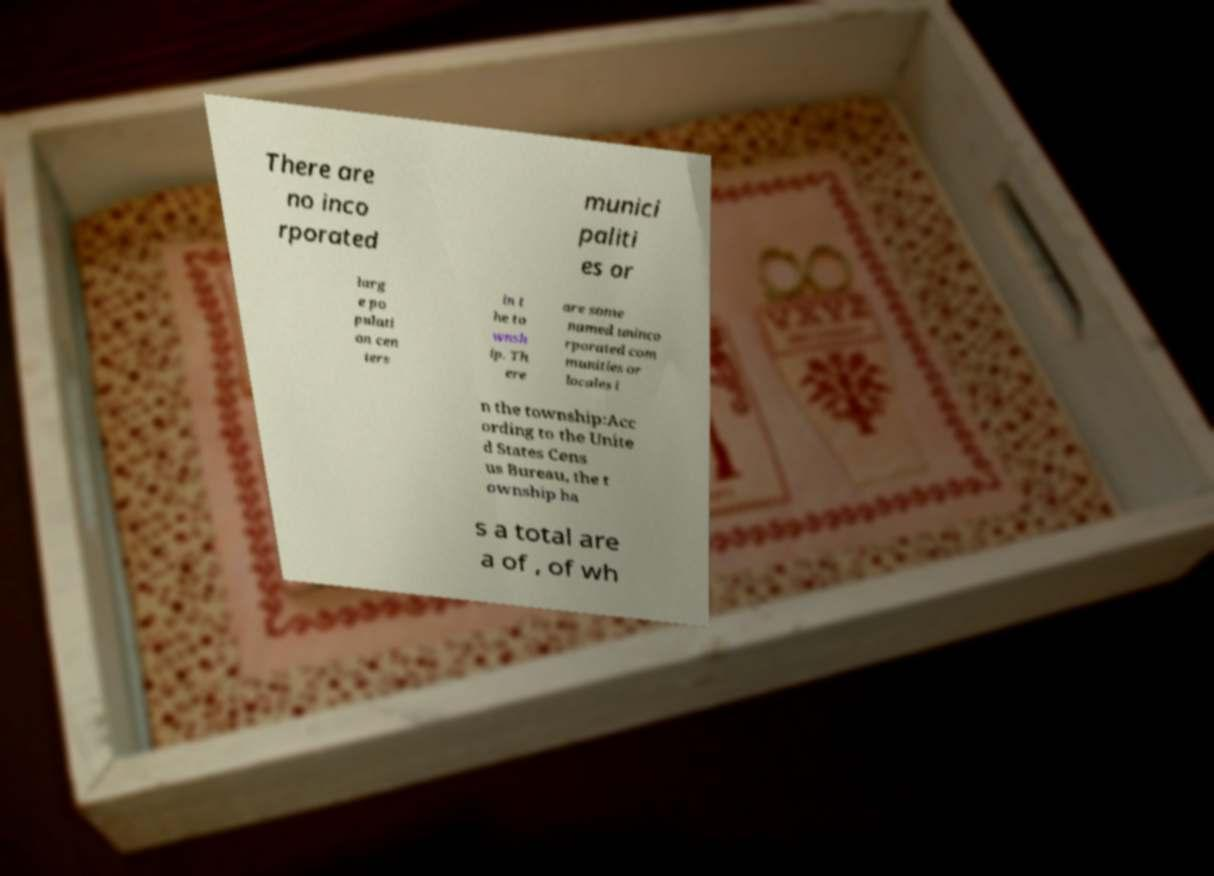There's text embedded in this image that I need extracted. Can you transcribe it verbatim? There are no inco rporated munici paliti es or larg e po pulati on cen ters in t he to wnsh ip. Th ere are some named uninco rporated com munities or locales i n the township:Acc ording to the Unite d States Cens us Bureau, the t ownship ha s a total are a of , of wh 